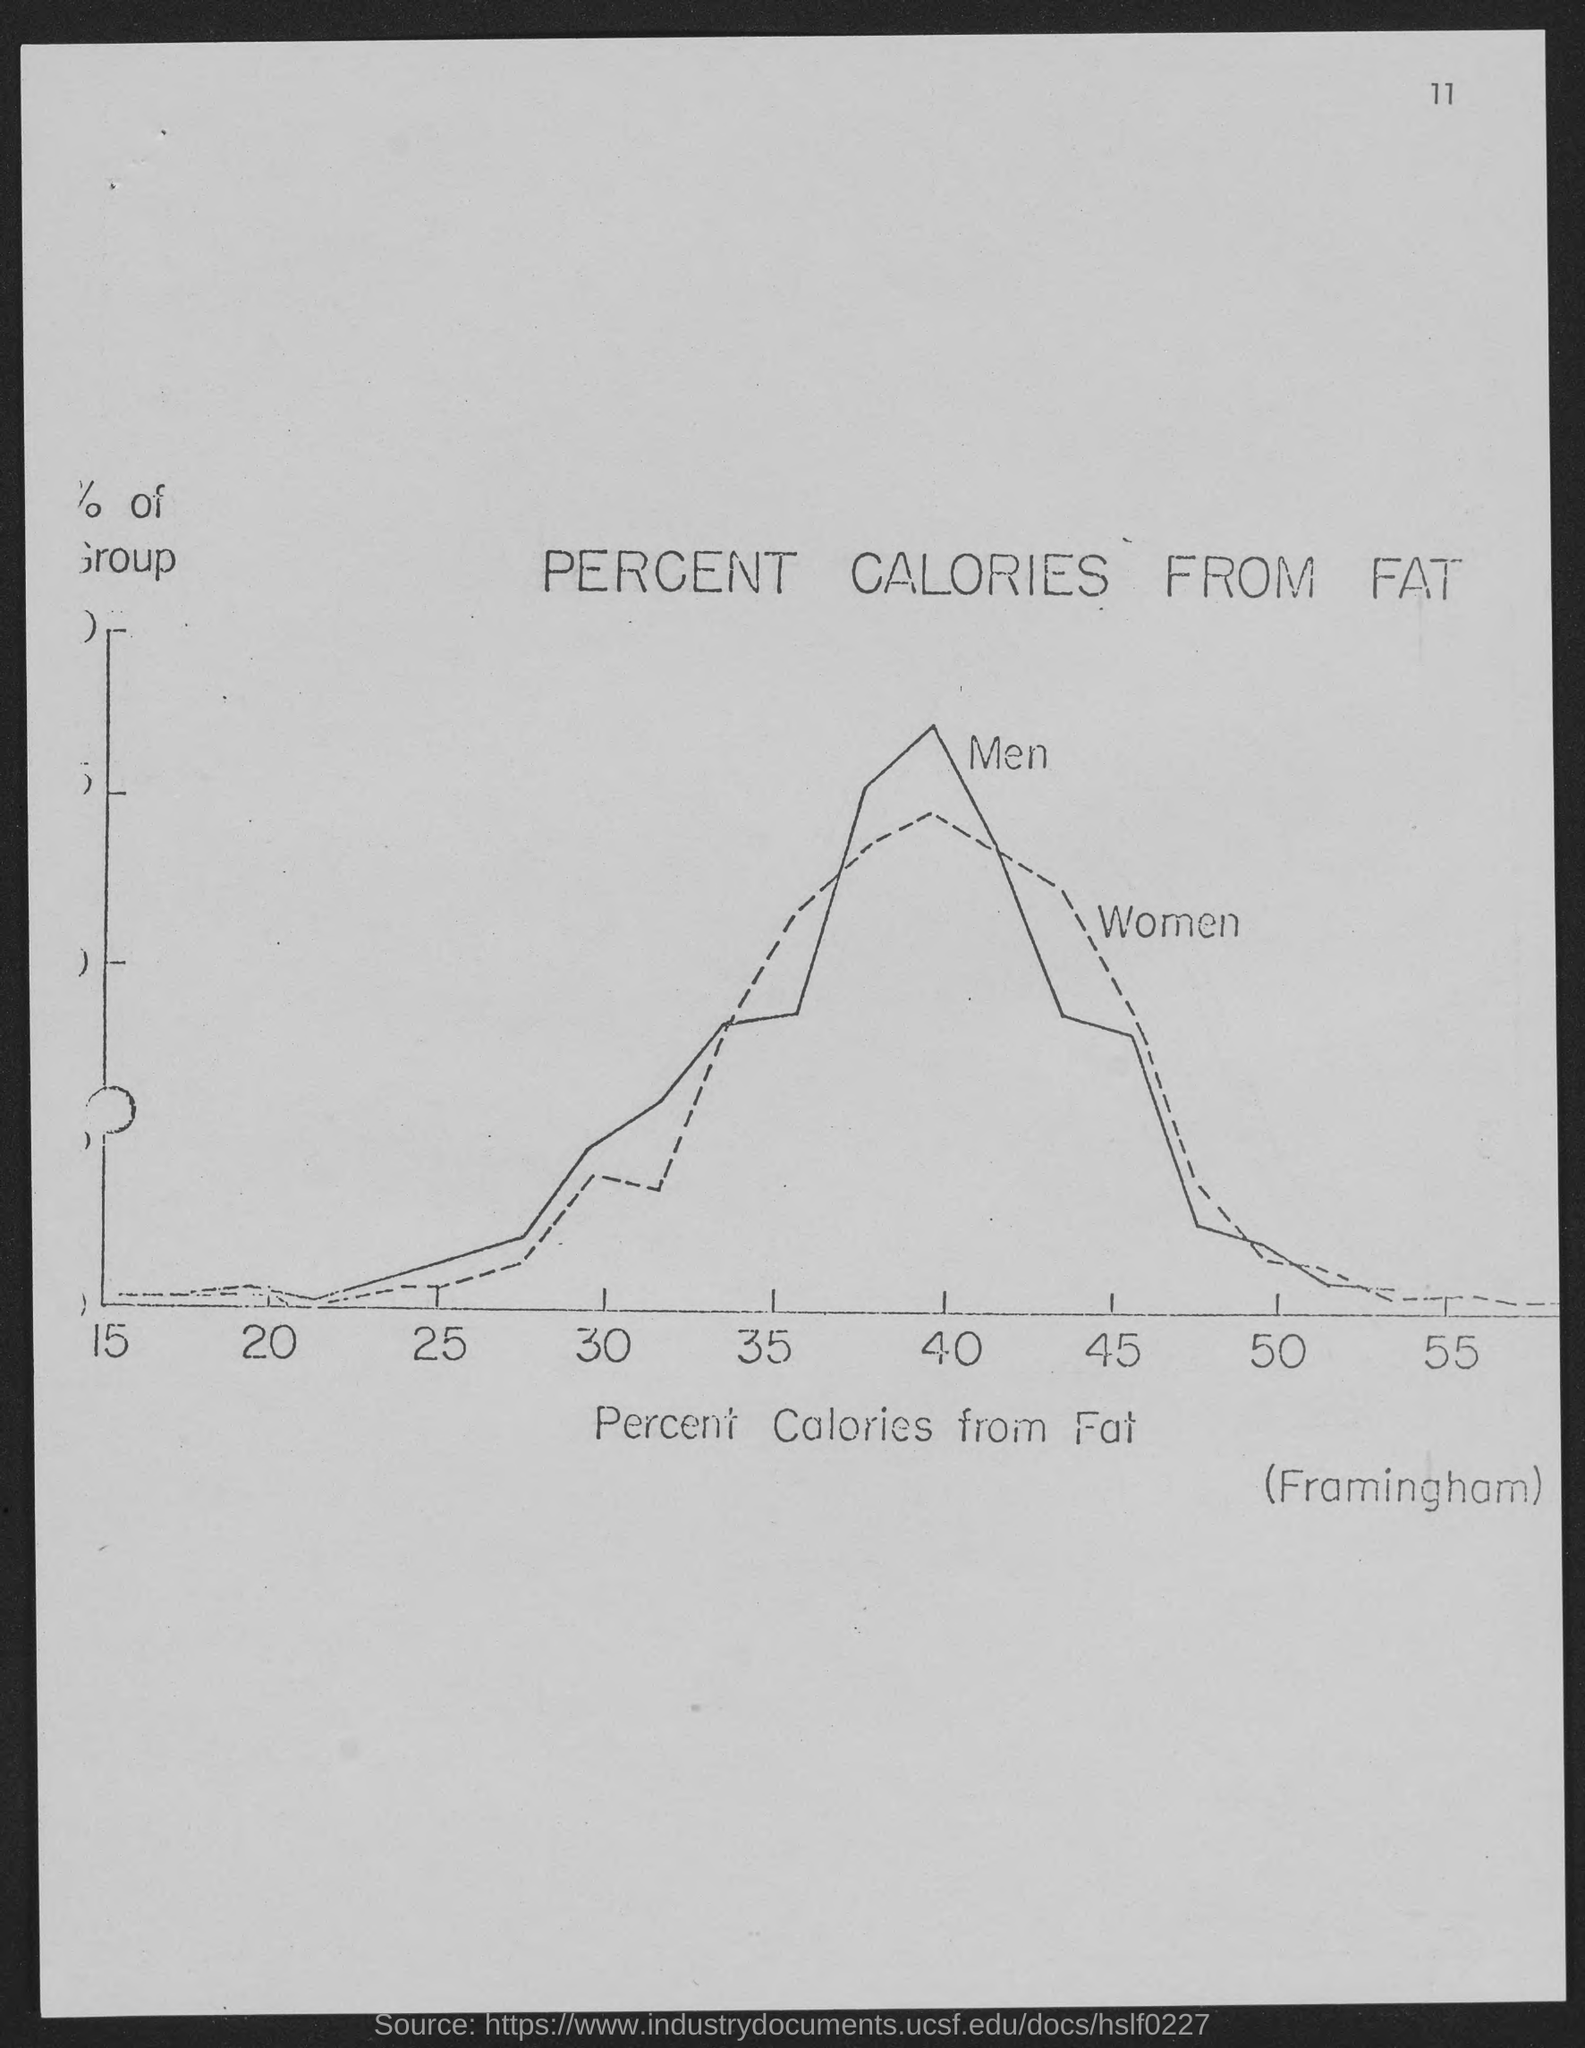What does x-axis on the graph represent?
Your answer should be very brief. Percent Calories from Fat. What is the page no mentioned in this document?
Make the answer very short. 11. 